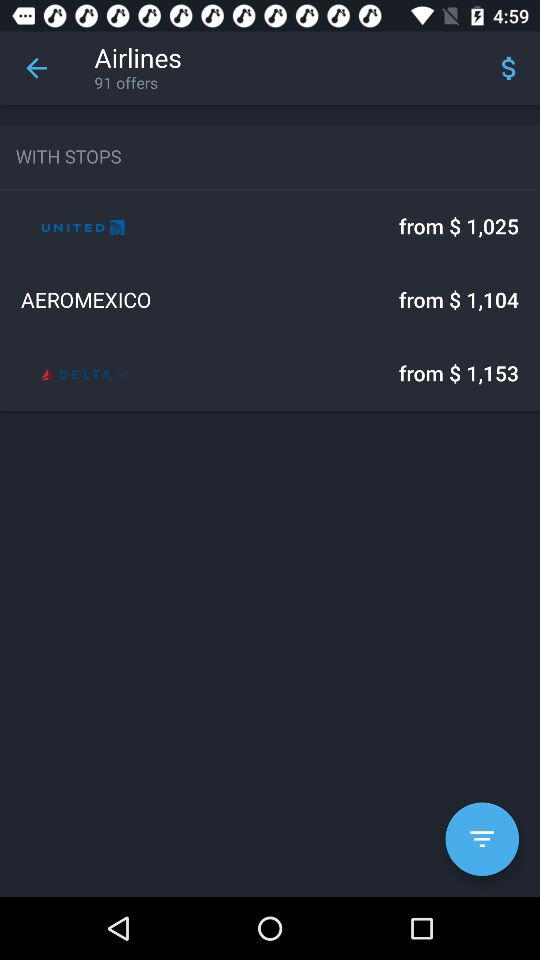How much do I have to pay for Delta airlines? You have to pay $1,153. 